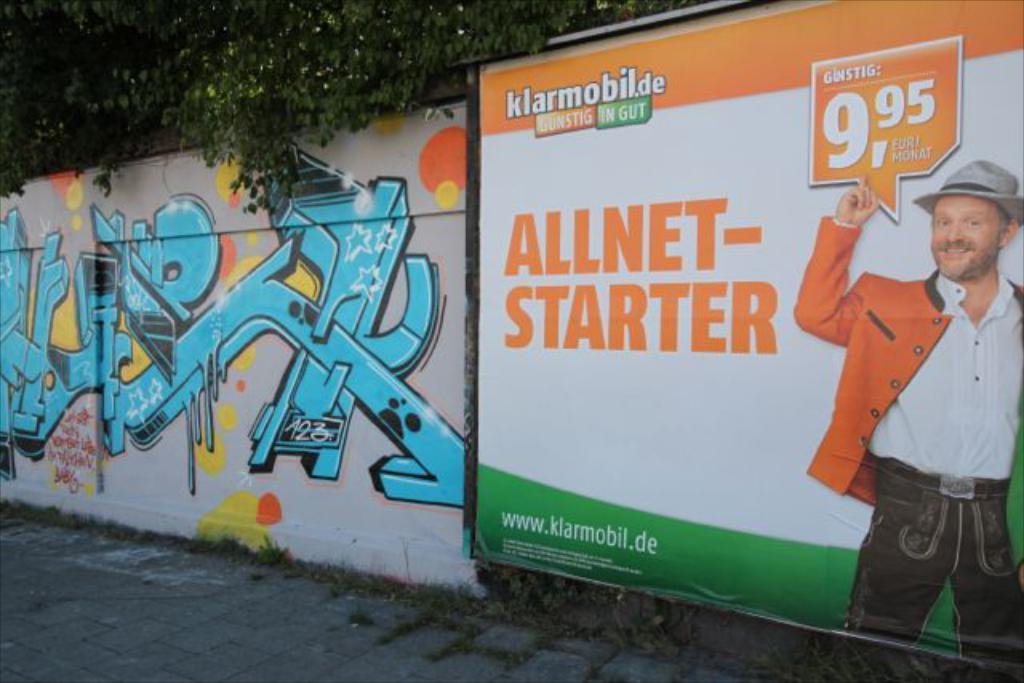<image>
Render a clear and concise summary of the photo. A billboard sign for Allnet-starter that costs 9,95 